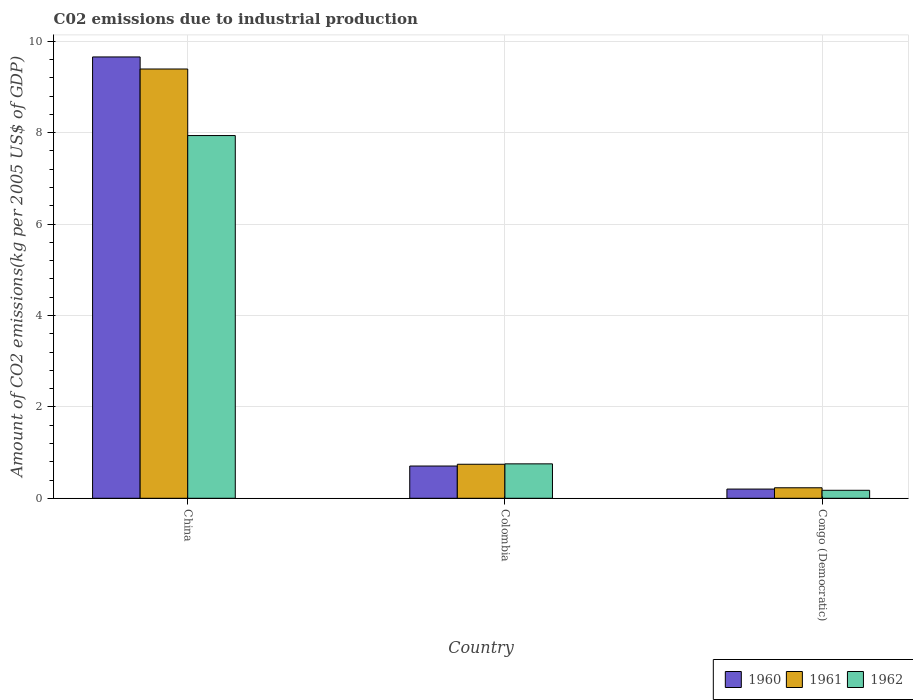How many groups of bars are there?
Provide a short and direct response. 3. Are the number of bars on each tick of the X-axis equal?
Offer a very short reply. Yes. How many bars are there on the 3rd tick from the left?
Ensure brevity in your answer.  3. What is the amount of CO2 emitted due to industrial production in 1961 in Congo (Democratic)?
Ensure brevity in your answer.  0.23. Across all countries, what is the maximum amount of CO2 emitted due to industrial production in 1962?
Offer a very short reply. 7.94. Across all countries, what is the minimum amount of CO2 emitted due to industrial production in 1962?
Your answer should be compact. 0.17. In which country was the amount of CO2 emitted due to industrial production in 1961 minimum?
Give a very brief answer. Congo (Democratic). What is the total amount of CO2 emitted due to industrial production in 1961 in the graph?
Your answer should be compact. 10.37. What is the difference between the amount of CO2 emitted due to industrial production in 1960 in China and that in Colombia?
Ensure brevity in your answer.  8.95. What is the difference between the amount of CO2 emitted due to industrial production in 1960 in Colombia and the amount of CO2 emitted due to industrial production in 1961 in China?
Provide a succinct answer. -8.69. What is the average amount of CO2 emitted due to industrial production in 1962 per country?
Provide a short and direct response. 2.96. What is the difference between the amount of CO2 emitted due to industrial production of/in 1960 and amount of CO2 emitted due to industrial production of/in 1961 in Congo (Democratic)?
Your answer should be very brief. -0.03. In how many countries, is the amount of CO2 emitted due to industrial production in 1962 greater than 9.2 kg?
Offer a terse response. 0. What is the ratio of the amount of CO2 emitted due to industrial production in 1961 in China to that in Congo (Democratic)?
Provide a short and direct response. 40.88. Is the amount of CO2 emitted due to industrial production in 1962 in China less than that in Colombia?
Provide a succinct answer. No. What is the difference between the highest and the second highest amount of CO2 emitted due to industrial production in 1961?
Provide a succinct answer. -8.65. What is the difference between the highest and the lowest amount of CO2 emitted due to industrial production in 1961?
Offer a terse response. 9.16. Is the sum of the amount of CO2 emitted due to industrial production in 1962 in China and Colombia greater than the maximum amount of CO2 emitted due to industrial production in 1961 across all countries?
Offer a terse response. No. What does the 1st bar from the right in Congo (Democratic) represents?
Keep it short and to the point. 1962. Is it the case that in every country, the sum of the amount of CO2 emitted due to industrial production in 1962 and amount of CO2 emitted due to industrial production in 1961 is greater than the amount of CO2 emitted due to industrial production in 1960?
Provide a succinct answer. Yes. Are all the bars in the graph horizontal?
Provide a succinct answer. No. Are the values on the major ticks of Y-axis written in scientific E-notation?
Your answer should be very brief. No. Does the graph contain grids?
Provide a succinct answer. Yes. How many legend labels are there?
Ensure brevity in your answer.  3. What is the title of the graph?
Your answer should be compact. C02 emissions due to industrial production. Does "1992" appear as one of the legend labels in the graph?
Keep it short and to the point. No. What is the label or title of the X-axis?
Give a very brief answer. Country. What is the label or title of the Y-axis?
Your response must be concise. Amount of CO2 emissions(kg per 2005 US$ of GDP). What is the Amount of CO2 emissions(kg per 2005 US$ of GDP) in 1960 in China?
Offer a very short reply. 9.66. What is the Amount of CO2 emissions(kg per 2005 US$ of GDP) in 1961 in China?
Offer a terse response. 9.39. What is the Amount of CO2 emissions(kg per 2005 US$ of GDP) of 1962 in China?
Provide a short and direct response. 7.94. What is the Amount of CO2 emissions(kg per 2005 US$ of GDP) of 1960 in Colombia?
Your answer should be compact. 0.71. What is the Amount of CO2 emissions(kg per 2005 US$ of GDP) of 1961 in Colombia?
Your answer should be very brief. 0.74. What is the Amount of CO2 emissions(kg per 2005 US$ of GDP) of 1962 in Colombia?
Provide a succinct answer. 0.75. What is the Amount of CO2 emissions(kg per 2005 US$ of GDP) in 1960 in Congo (Democratic)?
Offer a terse response. 0.2. What is the Amount of CO2 emissions(kg per 2005 US$ of GDP) in 1961 in Congo (Democratic)?
Your answer should be very brief. 0.23. What is the Amount of CO2 emissions(kg per 2005 US$ of GDP) in 1962 in Congo (Democratic)?
Provide a succinct answer. 0.17. Across all countries, what is the maximum Amount of CO2 emissions(kg per 2005 US$ of GDP) of 1960?
Your answer should be compact. 9.66. Across all countries, what is the maximum Amount of CO2 emissions(kg per 2005 US$ of GDP) in 1961?
Your response must be concise. 9.39. Across all countries, what is the maximum Amount of CO2 emissions(kg per 2005 US$ of GDP) of 1962?
Provide a short and direct response. 7.94. Across all countries, what is the minimum Amount of CO2 emissions(kg per 2005 US$ of GDP) in 1960?
Your answer should be very brief. 0.2. Across all countries, what is the minimum Amount of CO2 emissions(kg per 2005 US$ of GDP) in 1961?
Make the answer very short. 0.23. Across all countries, what is the minimum Amount of CO2 emissions(kg per 2005 US$ of GDP) of 1962?
Offer a very short reply. 0.17. What is the total Amount of CO2 emissions(kg per 2005 US$ of GDP) of 1960 in the graph?
Make the answer very short. 10.56. What is the total Amount of CO2 emissions(kg per 2005 US$ of GDP) in 1961 in the graph?
Your answer should be very brief. 10.37. What is the total Amount of CO2 emissions(kg per 2005 US$ of GDP) in 1962 in the graph?
Give a very brief answer. 8.87. What is the difference between the Amount of CO2 emissions(kg per 2005 US$ of GDP) in 1960 in China and that in Colombia?
Your answer should be compact. 8.95. What is the difference between the Amount of CO2 emissions(kg per 2005 US$ of GDP) of 1961 in China and that in Colombia?
Give a very brief answer. 8.65. What is the difference between the Amount of CO2 emissions(kg per 2005 US$ of GDP) in 1962 in China and that in Colombia?
Your response must be concise. 7.18. What is the difference between the Amount of CO2 emissions(kg per 2005 US$ of GDP) of 1960 in China and that in Congo (Democratic)?
Offer a terse response. 9.46. What is the difference between the Amount of CO2 emissions(kg per 2005 US$ of GDP) in 1961 in China and that in Congo (Democratic)?
Offer a very short reply. 9.16. What is the difference between the Amount of CO2 emissions(kg per 2005 US$ of GDP) in 1962 in China and that in Congo (Democratic)?
Ensure brevity in your answer.  7.76. What is the difference between the Amount of CO2 emissions(kg per 2005 US$ of GDP) in 1960 in Colombia and that in Congo (Democratic)?
Ensure brevity in your answer.  0.5. What is the difference between the Amount of CO2 emissions(kg per 2005 US$ of GDP) of 1961 in Colombia and that in Congo (Democratic)?
Provide a short and direct response. 0.51. What is the difference between the Amount of CO2 emissions(kg per 2005 US$ of GDP) of 1962 in Colombia and that in Congo (Democratic)?
Give a very brief answer. 0.58. What is the difference between the Amount of CO2 emissions(kg per 2005 US$ of GDP) of 1960 in China and the Amount of CO2 emissions(kg per 2005 US$ of GDP) of 1961 in Colombia?
Give a very brief answer. 8.91. What is the difference between the Amount of CO2 emissions(kg per 2005 US$ of GDP) in 1960 in China and the Amount of CO2 emissions(kg per 2005 US$ of GDP) in 1962 in Colombia?
Keep it short and to the point. 8.9. What is the difference between the Amount of CO2 emissions(kg per 2005 US$ of GDP) of 1961 in China and the Amount of CO2 emissions(kg per 2005 US$ of GDP) of 1962 in Colombia?
Make the answer very short. 8.64. What is the difference between the Amount of CO2 emissions(kg per 2005 US$ of GDP) of 1960 in China and the Amount of CO2 emissions(kg per 2005 US$ of GDP) of 1961 in Congo (Democratic)?
Give a very brief answer. 9.43. What is the difference between the Amount of CO2 emissions(kg per 2005 US$ of GDP) in 1960 in China and the Amount of CO2 emissions(kg per 2005 US$ of GDP) in 1962 in Congo (Democratic)?
Give a very brief answer. 9.48. What is the difference between the Amount of CO2 emissions(kg per 2005 US$ of GDP) in 1961 in China and the Amount of CO2 emissions(kg per 2005 US$ of GDP) in 1962 in Congo (Democratic)?
Offer a very short reply. 9.22. What is the difference between the Amount of CO2 emissions(kg per 2005 US$ of GDP) of 1960 in Colombia and the Amount of CO2 emissions(kg per 2005 US$ of GDP) of 1961 in Congo (Democratic)?
Your response must be concise. 0.48. What is the difference between the Amount of CO2 emissions(kg per 2005 US$ of GDP) of 1960 in Colombia and the Amount of CO2 emissions(kg per 2005 US$ of GDP) of 1962 in Congo (Democratic)?
Your response must be concise. 0.53. What is the difference between the Amount of CO2 emissions(kg per 2005 US$ of GDP) in 1961 in Colombia and the Amount of CO2 emissions(kg per 2005 US$ of GDP) in 1962 in Congo (Democratic)?
Give a very brief answer. 0.57. What is the average Amount of CO2 emissions(kg per 2005 US$ of GDP) of 1960 per country?
Give a very brief answer. 3.52. What is the average Amount of CO2 emissions(kg per 2005 US$ of GDP) in 1961 per country?
Provide a short and direct response. 3.46. What is the average Amount of CO2 emissions(kg per 2005 US$ of GDP) in 1962 per country?
Keep it short and to the point. 2.96. What is the difference between the Amount of CO2 emissions(kg per 2005 US$ of GDP) of 1960 and Amount of CO2 emissions(kg per 2005 US$ of GDP) of 1961 in China?
Your answer should be very brief. 0.26. What is the difference between the Amount of CO2 emissions(kg per 2005 US$ of GDP) of 1960 and Amount of CO2 emissions(kg per 2005 US$ of GDP) of 1962 in China?
Provide a succinct answer. 1.72. What is the difference between the Amount of CO2 emissions(kg per 2005 US$ of GDP) in 1961 and Amount of CO2 emissions(kg per 2005 US$ of GDP) in 1962 in China?
Your answer should be very brief. 1.46. What is the difference between the Amount of CO2 emissions(kg per 2005 US$ of GDP) of 1960 and Amount of CO2 emissions(kg per 2005 US$ of GDP) of 1961 in Colombia?
Ensure brevity in your answer.  -0.04. What is the difference between the Amount of CO2 emissions(kg per 2005 US$ of GDP) in 1960 and Amount of CO2 emissions(kg per 2005 US$ of GDP) in 1962 in Colombia?
Keep it short and to the point. -0.05. What is the difference between the Amount of CO2 emissions(kg per 2005 US$ of GDP) of 1961 and Amount of CO2 emissions(kg per 2005 US$ of GDP) of 1962 in Colombia?
Ensure brevity in your answer.  -0.01. What is the difference between the Amount of CO2 emissions(kg per 2005 US$ of GDP) in 1960 and Amount of CO2 emissions(kg per 2005 US$ of GDP) in 1961 in Congo (Democratic)?
Offer a very short reply. -0.03. What is the difference between the Amount of CO2 emissions(kg per 2005 US$ of GDP) in 1960 and Amount of CO2 emissions(kg per 2005 US$ of GDP) in 1962 in Congo (Democratic)?
Give a very brief answer. 0.03. What is the difference between the Amount of CO2 emissions(kg per 2005 US$ of GDP) of 1961 and Amount of CO2 emissions(kg per 2005 US$ of GDP) of 1962 in Congo (Democratic)?
Make the answer very short. 0.05. What is the ratio of the Amount of CO2 emissions(kg per 2005 US$ of GDP) in 1960 in China to that in Colombia?
Your response must be concise. 13.68. What is the ratio of the Amount of CO2 emissions(kg per 2005 US$ of GDP) of 1961 in China to that in Colombia?
Your answer should be compact. 12.62. What is the ratio of the Amount of CO2 emissions(kg per 2005 US$ of GDP) of 1962 in China to that in Colombia?
Your answer should be compact. 10.54. What is the ratio of the Amount of CO2 emissions(kg per 2005 US$ of GDP) of 1960 in China to that in Congo (Democratic)?
Give a very brief answer. 47.89. What is the ratio of the Amount of CO2 emissions(kg per 2005 US$ of GDP) in 1961 in China to that in Congo (Democratic)?
Provide a succinct answer. 40.88. What is the ratio of the Amount of CO2 emissions(kg per 2005 US$ of GDP) in 1962 in China to that in Congo (Democratic)?
Your answer should be very brief. 45.4. What is the ratio of the Amount of CO2 emissions(kg per 2005 US$ of GDP) in 1960 in Colombia to that in Congo (Democratic)?
Keep it short and to the point. 3.5. What is the ratio of the Amount of CO2 emissions(kg per 2005 US$ of GDP) of 1961 in Colombia to that in Congo (Democratic)?
Your answer should be very brief. 3.24. What is the ratio of the Amount of CO2 emissions(kg per 2005 US$ of GDP) of 1962 in Colombia to that in Congo (Democratic)?
Your answer should be very brief. 4.31. What is the difference between the highest and the second highest Amount of CO2 emissions(kg per 2005 US$ of GDP) in 1960?
Offer a very short reply. 8.95. What is the difference between the highest and the second highest Amount of CO2 emissions(kg per 2005 US$ of GDP) of 1961?
Keep it short and to the point. 8.65. What is the difference between the highest and the second highest Amount of CO2 emissions(kg per 2005 US$ of GDP) in 1962?
Ensure brevity in your answer.  7.18. What is the difference between the highest and the lowest Amount of CO2 emissions(kg per 2005 US$ of GDP) of 1960?
Provide a short and direct response. 9.46. What is the difference between the highest and the lowest Amount of CO2 emissions(kg per 2005 US$ of GDP) in 1961?
Your response must be concise. 9.16. What is the difference between the highest and the lowest Amount of CO2 emissions(kg per 2005 US$ of GDP) in 1962?
Your answer should be compact. 7.76. 